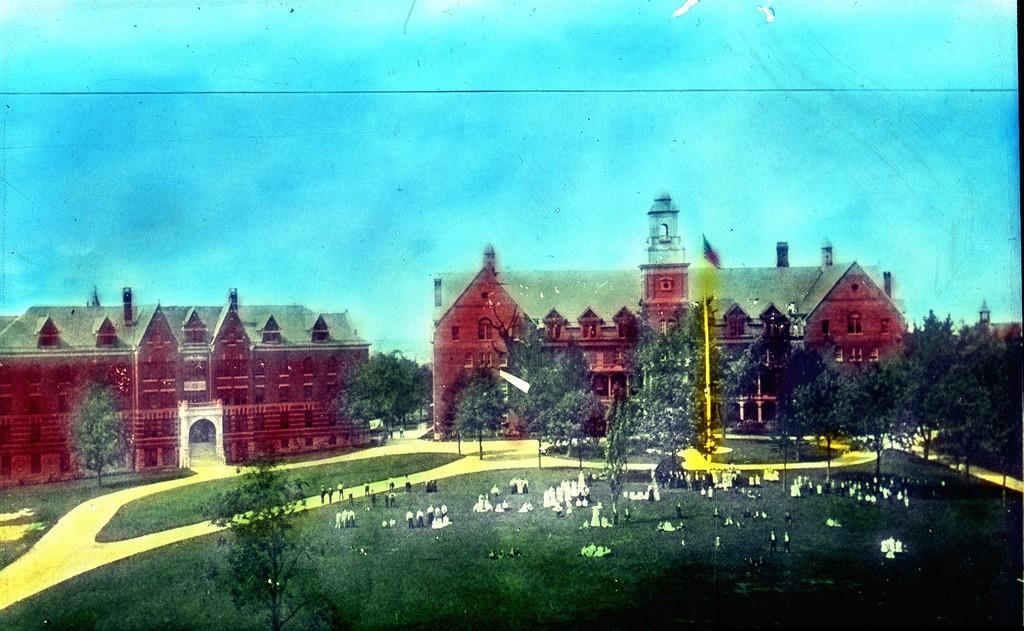Describe this image in one or two sentences. This picture seems to be an edited image. In the foreground, we can see the green grass, group of people, trees and some other objects. In the background, we can see the sky, trees and buildings. 